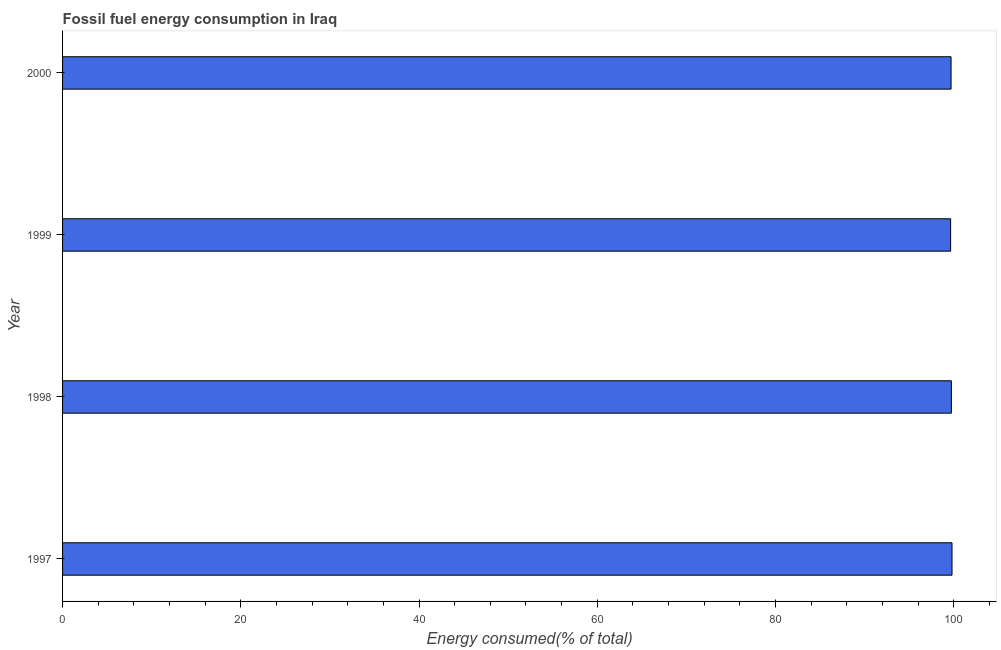Does the graph contain grids?
Ensure brevity in your answer.  No. What is the title of the graph?
Your response must be concise. Fossil fuel energy consumption in Iraq. What is the label or title of the X-axis?
Your answer should be very brief. Energy consumed(% of total). What is the fossil fuel energy consumption in 1997?
Offer a terse response. 99.8. Across all years, what is the maximum fossil fuel energy consumption?
Your answer should be compact. 99.8. Across all years, what is the minimum fossil fuel energy consumption?
Provide a short and direct response. 99.65. In which year was the fossil fuel energy consumption maximum?
Your response must be concise. 1997. What is the sum of the fossil fuel energy consumption?
Provide a succinct answer. 398.88. What is the difference between the fossil fuel energy consumption in 1998 and 1999?
Your response must be concise. 0.09. What is the average fossil fuel energy consumption per year?
Offer a terse response. 99.72. What is the median fossil fuel energy consumption?
Your answer should be very brief. 99.71. In how many years, is the fossil fuel energy consumption greater than 88 %?
Your response must be concise. 4. Do a majority of the years between 1999 and 1998 (inclusive) have fossil fuel energy consumption greater than 32 %?
Give a very brief answer. No. Is the fossil fuel energy consumption in 1997 less than that in 2000?
Provide a succinct answer. No. What is the difference between the highest and the second highest fossil fuel energy consumption?
Your answer should be compact. 0.07. Is the sum of the fossil fuel energy consumption in 1998 and 2000 greater than the maximum fossil fuel energy consumption across all years?
Ensure brevity in your answer.  Yes. What is the difference between the highest and the lowest fossil fuel energy consumption?
Keep it short and to the point. 0.16. What is the difference between two consecutive major ticks on the X-axis?
Make the answer very short. 20. What is the Energy consumed(% of total) of 1997?
Offer a very short reply. 99.8. What is the Energy consumed(% of total) of 1998?
Offer a very short reply. 99.73. What is the Energy consumed(% of total) of 1999?
Provide a succinct answer. 99.65. What is the Energy consumed(% of total) in 2000?
Give a very brief answer. 99.7. What is the difference between the Energy consumed(% of total) in 1997 and 1998?
Your answer should be very brief. 0.07. What is the difference between the Energy consumed(% of total) in 1997 and 1999?
Your response must be concise. 0.16. What is the difference between the Energy consumed(% of total) in 1997 and 2000?
Ensure brevity in your answer.  0.11. What is the difference between the Energy consumed(% of total) in 1998 and 1999?
Keep it short and to the point. 0.09. What is the difference between the Energy consumed(% of total) in 1998 and 2000?
Provide a short and direct response. 0.04. What is the difference between the Energy consumed(% of total) in 1999 and 2000?
Offer a terse response. -0.05. What is the ratio of the Energy consumed(% of total) in 1997 to that in 1998?
Your answer should be compact. 1. What is the ratio of the Energy consumed(% of total) in 1997 to that in 2000?
Ensure brevity in your answer.  1. What is the ratio of the Energy consumed(% of total) in 1999 to that in 2000?
Provide a succinct answer. 1. 